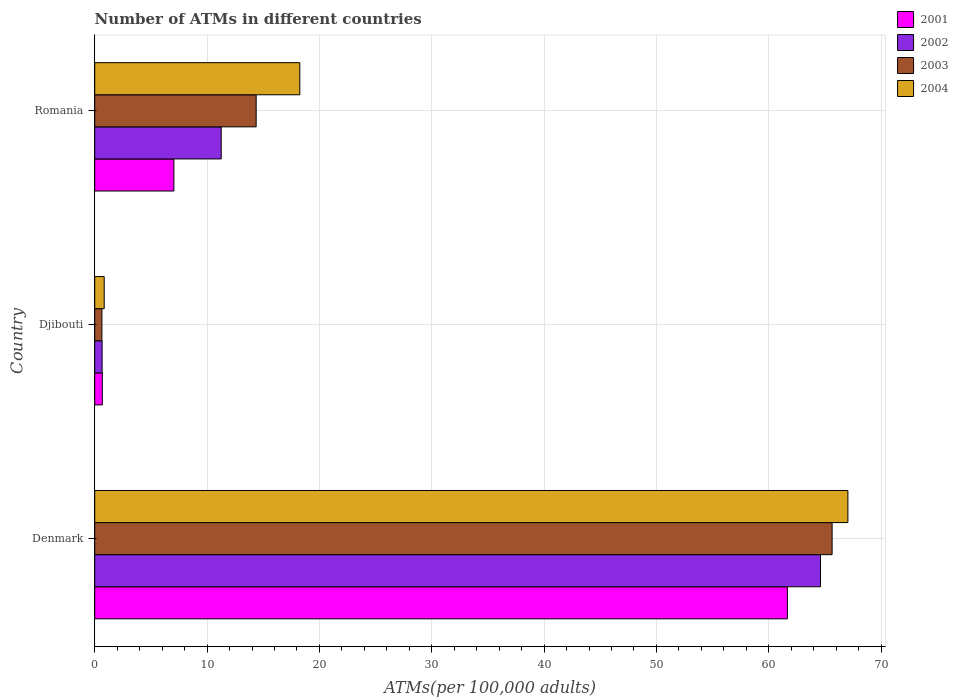How many different coloured bars are there?
Provide a short and direct response. 4. How many groups of bars are there?
Give a very brief answer. 3. Are the number of bars on each tick of the Y-axis equal?
Give a very brief answer. Yes. How many bars are there on the 1st tick from the bottom?
Your answer should be very brief. 4. What is the label of the 1st group of bars from the top?
Your answer should be compact. Romania. In how many cases, is the number of bars for a given country not equal to the number of legend labels?
Keep it short and to the point. 0. What is the number of ATMs in 2001 in Romania?
Give a very brief answer. 7.04. Across all countries, what is the maximum number of ATMs in 2003?
Provide a short and direct response. 65.64. Across all countries, what is the minimum number of ATMs in 2001?
Your response must be concise. 0.68. In which country was the number of ATMs in 2004 maximum?
Offer a terse response. Denmark. In which country was the number of ATMs in 2002 minimum?
Offer a terse response. Djibouti. What is the total number of ATMs in 2004 in the graph?
Give a very brief answer. 86.14. What is the difference between the number of ATMs in 2001 in Djibouti and that in Romania?
Offer a very short reply. -6.37. What is the difference between the number of ATMs in 2001 in Denmark and the number of ATMs in 2004 in Djibouti?
Offer a very short reply. 60.81. What is the average number of ATMs in 2001 per country?
Your answer should be compact. 23.13. What is the difference between the number of ATMs in 2003 and number of ATMs in 2002 in Denmark?
Provide a succinct answer. 1.03. In how many countries, is the number of ATMs in 2003 greater than 4 ?
Your response must be concise. 2. What is the ratio of the number of ATMs in 2003 in Denmark to that in Romania?
Make the answer very short. 4.57. Is the number of ATMs in 2002 in Denmark less than that in Romania?
Offer a terse response. No. Is the difference between the number of ATMs in 2003 in Denmark and Djibouti greater than the difference between the number of ATMs in 2002 in Denmark and Djibouti?
Your answer should be compact. Yes. What is the difference between the highest and the second highest number of ATMs in 2003?
Your answer should be very brief. 51.27. What is the difference between the highest and the lowest number of ATMs in 2001?
Your answer should be compact. 60.98. In how many countries, is the number of ATMs in 2004 greater than the average number of ATMs in 2004 taken over all countries?
Make the answer very short. 1. Is it the case that in every country, the sum of the number of ATMs in 2004 and number of ATMs in 2001 is greater than the sum of number of ATMs in 2003 and number of ATMs in 2002?
Offer a very short reply. No. What does the 2nd bar from the top in Djibouti represents?
Offer a very short reply. 2003. What does the 3rd bar from the bottom in Denmark represents?
Ensure brevity in your answer.  2003. How many bars are there?
Your response must be concise. 12. Are all the bars in the graph horizontal?
Offer a very short reply. Yes. What is the difference between two consecutive major ticks on the X-axis?
Your response must be concise. 10. Are the values on the major ticks of X-axis written in scientific E-notation?
Ensure brevity in your answer.  No. Does the graph contain any zero values?
Offer a very short reply. No. Does the graph contain grids?
Make the answer very short. Yes. Where does the legend appear in the graph?
Provide a succinct answer. Top right. How are the legend labels stacked?
Your answer should be compact. Vertical. What is the title of the graph?
Give a very brief answer. Number of ATMs in different countries. Does "2015" appear as one of the legend labels in the graph?
Provide a succinct answer. No. What is the label or title of the X-axis?
Provide a succinct answer. ATMs(per 100,0 adults). What is the label or title of the Y-axis?
Make the answer very short. Country. What is the ATMs(per 100,000 adults) of 2001 in Denmark?
Provide a short and direct response. 61.66. What is the ATMs(per 100,000 adults) of 2002 in Denmark?
Your answer should be compact. 64.61. What is the ATMs(per 100,000 adults) in 2003 in Denmark?
Provide a succinct answer. 65.64. What is the ATMs(per 100,000 adults) in 2004 in Denmark?
Make the answer very short. 67.04. What is the ATMs(per 100,000 adults) of 2001 in Djibouti?
Your answer should be very brief. 0.68. What is the ATMs(per 100,000 adults) of 2002 in Djibouti?
Make the answer very short. 0.66. What is the ATMs(per 100,000 adults) in 2003 in Djibouti?
Provide a short and direct response. 0.64. What is the ATMs(per 100,000 adults) of 2004 in Djibouti?
Keep it short and to the point. 0.84. What is the ATMs(per 100,000 adults) of 2001 in Romania?
Ensure brevity in your answer.  7.04. What is the ATMs(per 100,000 adults) in 2002 in Romania?
Provide a succinct answer. 11.26. What is the ATMs(per 100,000 adults) of 2003 in Romania?
Your response must be concise. 14.37. What is the ATMs(per 100,000 adults) in 2004 in Romania?
Your response must be concise. 18.26. Across all countries, what is the maximum ATMs(per 100,000 adults) in 2001?
Offer a terse response. 61.66. Across all countries, what is the maximum ATMs(per 100,000 adults) of 2002?
Offer a terse response. 64.61. Across all countries, what is the maximum ATMs(per 100,000 adults) of 2003?
Provide a succinct answer. 65.64. Across all countries, what is the maximum ATMs(per 100,000 adults) of 2004?
Make the answer very short. 67.04. Across all countries, what is the minimum ATMs(per 100,000 adults) of 2001?
Your response must be concise. 0.68. Across all countries, what is the minimum ATMs(per 100,000 adults) of 2002?
Provide a short and direct response. 0.66. Across all countries, what is the minimum ATMs(per 100,000 adults) in 2003?
Keep it short and to the point. 0.64. Across all countries, what is the minimum ATMs(per 100,000 adults) of 2004?
Provide a succinct answer. 0.84. What is the total ATMs(per 100,000 adults) in 2001 in the graph?
Give a very brief answer. 69.38. What is the total ATMs(per 100,000 adults) of 2002 in the graph?
Give a very brief answer. 76.52. What is the total ATMs(per 100,000 adults) in 2003 in the graph?
Make the answer very short. 80.65. What is the total ATMs(per 100,000 adults) in 2004 in the graph?
Keep it short and to the point. 86.14. What is the difference between the ATMs(per 100,000 adults) of 2001 in Denmark and that in Djibouti?
Offer a terse response. 60.98. What is the difference between the ATMs(per 100,000 adults) of 2002 in Denmark and that in Djibouti?
Your answer should be very brief. 63.95. What is the difference between the ATMs(per 100,000 adults) in 2003 in Denmark and that in Djibouti?
Keep it short and to the point. 65. What is the difference between the ATMs(per 100,000 adults) of 2004 in Denmark and that in Djibouti?
Keep it short and to the point. 66.2. What is the difference between the ATMs(per 100,000 adults) in 2001 in Denmark and that in Romania?
Your answer should be compact. 54.61. What is the difference between the ATMs(per 100,000 adults) in 2002 in Denmark and that in Romania?
Give a very brief answer. 53.35. What is the difference between the ATMs(per 100,000 adults) of 2003 in Denmark and that in Romania?
Give a very brief answer. 51.27. What is the difference between the ATMs(per 100,000 adults) of 2004 in Denmark and that in Romania?
Provide a short and direct response. 48.79. What is the difference between the ATMs(per 100,000 adults) in 2001 in Djibouti and that in Romania?
Provide a succinct answer. -6.37. What is the difference between the ATMs(per 100,000 adults) of 2002 in Djibouti and that in Romania?
Your answer should be very brief. -10.6. What is the difference between the ATMs(per 100,000 adults) in 2003 in Djibouti and that in Romania?
Ensure brevity in your answer.  -13.73. What is the difference between the ATMs(per 100,000 adults) of 2004 in Djibouti and that in Romania?
Give a very brief answer. -17.41. What is the difference between the ATMs(per 100,000 adults) of 2001 in Denmark and the ATMs(per 100,000 adults) of 2002 in Djibouti?
Keep it short and to the point. 61. What is the difference between the ATMs(per 100,000 adults) of 2001 in Denmark and the ATMs(per 100,000 adults) of 2003 in Djibouti?
Your response must be concise. 61.02. What is the difference between the ATMs(per 100,000 adults) of 2001 in Denmark and the ATMs(per 100,000 adults) of 2004 in Djibouti?
Offer a very short reply. 60.81. What is the difference between the ATMs(per 100,000 adults) in 2002 in Denmark and the ATMs(per 100,000 adults) in 2003 in Djibouti?
Offer a very short reply. 63.97. What is the difference between the ATMs(per 100,000 adults) of 2002 in Denmark and the ATMs(per 100,000 adults) of 2004 in Djibouti?
Your answer should be compact. 63.76. What is the difference between the ATMs(per 100,000 adults) of 2003 in Denmark and the ATMs(per 100,000 adults) of 2004 in Djibouti?
Keep it short and to the point. 64.79. What is the difference between the ATMs(per 100,000 adults) in 2001 in Denmark and the ATMs(per 100,000 adults) in 2002 in Romania?
Keep it short and to the point. 50.4. What is the difference between the ATMs(per 100,000 adults) of 2001 in Denmark and the ATMs(per 100,000 adults) of 2003 in Romania?
Offer a terse response. 47.29. What is the difference between the ATMs(per 100,000 adults) of 2001 in Denmark and the ATMs(per 100,000 adults) of 2004 in Romania?
Make the answer very short. 43.4. What is the difference between the ATMs(per 100,000 adults) of 2002 in Denmark and the ATMs(per 100,000 adults) of 2003 in Romania?
Give a very brief answer. 50.24. What is the difference between the ATMs(per 100,000 adults) of 2002 in Denmark and the ATMs(per 100,000 adults) of 2004 in Romania?
Offer a very short reply. 46.35. What is the difference between the ATMs(per 100,000 adults) in 2003 in Denmark and the ATMs(per 100,000 adults) in 2004 in Romania?
Keep it short and to the point. 47.38. What is the difference between the ATMs(per 100,000 adults) in 2001 in Djibouti and the ATMs(per 100,000 adults) in 2002 in Romania?
Provide a succinct answer. -10.58. What is the difference between the ATMs(per 100,000 adults) of 2001 in Djibouti and the ATMs(per 100,000 adults) of 2003 in Romania?
Your response must be concise. -13.69. What is the difference between the ATMs(per 100,000 adults) of 2001 in Djibouti and the ATMs(per 100,000 adults) of 2004 in Romania?
Ensure brevity in your answer.  -17.58. What is the difference between the ATMs(per 100,000 adults) in 2002 in Djibouti and the ATMs(per 100,000 adults) in 2003 in Romania?
Your answer should be very brief. -13.71. What is the difference between the ATMs(per 100,000 adults) in 2002 in Djibouti and the ATMs(per 100,000 adults) in 2004 in Romania?
Provide a short and direct response. -17.6. What is the difference between the ATMs(per 100,000 adults) in 2003 in Djibouti and the ATMs(per 100,000 adults) in 2004 in Romania?
Make the answer very short. -17.62. What is the average ATMs(per 100,000 adults) of 2001 per country?
Your answer should be very brief. 23.13. What is the average ATMs(per 100,000 adults) in 2002 per country?
Your answer should be compact. 25.51. What is the average ATMs(per 100,000 adults) in 2003 per country?
Offer a terse response. 26.88. What is the average ATMs(per 100,000 adults) of 2004 per country?
Your response must be concise. 28.71. What is the difference between the ATMs(per 100,000 adults) of 2001 and ATMs(per 100,000 adults) of 2002 in Denmark?
Ensure brevity in your answer.  -2.95. What is the difference between the ATMs(per 100,000 adults) of 2001 and ATMs(per 100,000 adults) of 2003 in Denmark?
Your answer should be compact. -3.98. What is the difference between the ATMs(per 100,000 adults) of 2001 and ATMs(per 100,000 adults) of 2004 in Denmark?
Ensure brevity in your answer.  -5.39. What is the difference between the ATMs(per 100,000 adults) of 2002 and ATMs(per 100,000 adults) of 2003 in Denmark?
Your answer should be very brief. -1.03. What is the difference between the ATMs(per 100,000 adults) in 2002 and ATMs(per 100,000 adults) in 2004 in Denmark?
Your response must be concise. -2.44. What is the difference between the ATMs(per 100,000 adults) in 2003 and ATMs(per 100,000 adults) in 2004 in Denmark?
Provide a succinct answer. -1.41. What is the difference between the ATMs(per 100,000 adults) in 2001 and ATMs(per 100,000 adults) in 2002 in Djibouti?
Provide a short and direct response. 0.02. What is the difference between the ATMs(per 100,000 adults) of 2001 and ATMs(per 100,000 adults) of 2003 in Djibouti?
Make the answer very short. 0.04. What is the difference between the ATMs(per 100,000 adults) in 2001 and ATMs(per 100,000 adults) in 2004 in Djibouti?
Keep it short and to the point. -0.17. What is the difference between the ATMs(per 100,000 adults) of 2002 and ATMs(per 100,000 adults) of 2003 in Djibouti?
Offer a very short reply. 0.02. What is the difference between the ATMs(per 100,000 adults) of 2002 and ATMs(per 100,000 adults) of 2004 in Djibouti?
Offer a terse response. -0.19. What is the difference between the ATMs(per 100,000 adults) of 2003 and ATMs(per 100,000 adults) of 2004 in Djibouti?
Your answer should be compact. -0.21. What is the difference between the ATMs(per 100,000 adults) of 2001 and ATMs(per 100,000 adults) of 2002 in Romania?
Your answer should be very brief. -4.21. What is the difference between the ATMs(per 100,000 adults) of 2001 and ATMs(per 100,000 adults) of 2003 in Romania?
Keep it short and to the point. -7.32. What is the difference between the ATMs(per 100,000 adults) of 2001 and ATMs(per 100,000 adults) of 2004 in Romania?
Make the answer very short. -11.21. What is the difference between the ATMs(per 100,000 adults) in 2002 and ATMs(per 100,000 adults) in 2003 in Romania?
Provide a short and direct response. -3.11. What is the difference between the ATMs(per 100,000 adults) in 2002 and ATMs(per 100,000 adults) in 2004 in Romania?
Offer a very short reply. -7. What is the difference between the ATMs(per 100,000 adults) in 2003 and ATMs(per 100,000 adults) in 2004 in Romania?
Your answer should be compact. -3.89. What is the ratio of the ATMs(per 100,000 adults) of 2001 in Denmark to that in Djibouti?
Ensure brevity in your answer.  91.18. What is the ratio of the ATMs(per 100,000 adults) in 2002 in Denmark to that in Djibouti?
Your response must be concise. 98.45. What is the ratio of the ATMs(per 100,000 adults) in 2003 in Denmark to that in Djibouti?
Your response must be concise. 102.88. What is the ratio of the ATMs(per 100,000 adults) of 2004 in Denmark to that in Djibouti?
Ensure brevity in your answer.  79.46. What is the ratio of the ATMs(per 100,000 adults) of 2001 in Denmark to that in Romania?
Provide a succinct answer. 8.75. What is the ratio of the ATMs(per 100,000 adults) in 2002 in Denmark to that in Romania?
Ensure brevity in your answer.  5.74. What is the ratio of the ATMs(per 100,000 adults) in 2003 in Denmark to that in Romania?
Ensure brevity in your answer.  4.57. What is the ratio of the ATMs(per 100,000 adults) in 2004 in Denmark to that in Romania?
Provide a succinct answer. 3.67. What is the ratio of the ATMs(per 100,000 adults) in 2001 in Djibouti to that in Romania?
Your answer should be very brief. 0.1. What is the ratio of the ATMs(per 100,000 adults) of 2002 in Djibouti to that in Romania?
Offer a very short reply. 0.06. What is the ratio of the ATMs(per 100,000 adults) of 2003 in Djibouti to that in Romania?
Your answer should be compact. 0.04. What is the ratio of the ATMs(per 100,000 adults) of 2004 in Djibouti to that in Romania?
Give a very brief answer. 0.05. What is the difference between the highest and the second highest ATMs(per 100,000 adults) in 2001?
Your answer should be very brief. 54.61. What is the difference between the highest and the second highest ATMs(per 100,000 adults) of 2002?
Offer a very short reply. 53.35. What is the difference between the highest and the second highest ATMs(per 100,000 adults) of 2003?
Offer a terse response. 51.27. What is the difference between the highest and the second highest ATMs(per 100,000 adults) of 2004?
Your response must be concise. 48.79. What is the difference between the highest and the lowest ATMs(per 100,000 adults) of 2001?
Make the answer very short. 60.98. What is the difference between the highest and the lowest ATMs(per 100,000 adults) of 2002?
Make the answer very short. 63.95. What is the difference between the highest and the lowest ATMs(per 100,000 adults) of 2003?
Provide a short and direct response. 65. What is the difference between the highest and the lowest ATMs(per 100,000 adults) of 2004?
Provide a succinct answer. 66.2. 